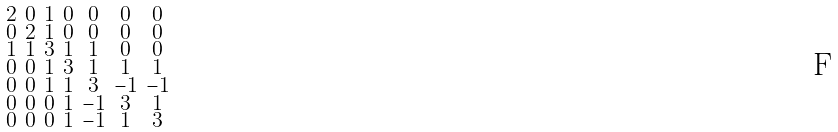Convert formula to latex. <formula><loc_0><loc_0><loc_500><loc_500>\begin{smallmatrix} 2 & 0 & 1 & 0 & 0 & 0 & 0 \\ 0 & 2 & 1 & 0 & 0 & 0 & 0 \\ 1 & 1 & 3 & 1 & 1 & 0 & 0 \\ 0 & 0 & 1 & 3 & 1 & 1 & 1 \\ 0 & 0 & 1 & 1 & 3 & - 1 & - 1 \\ 0 & 0 & 0 & 1 & - 1 & 3 & 1 \\ 0 & 0 & 0 & 1 & - 1 & 1 & 3 \end{smallmatrix}</formula> 